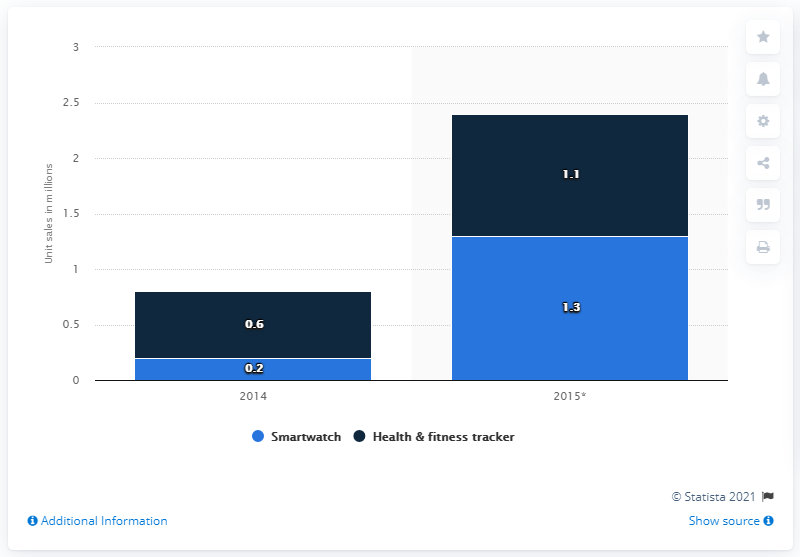Highlight a few significant elements in this photo. According to forecasts, it is expected that 1.3 units of smartwatches will be sold in Central and Eastern Europe in 2015. 